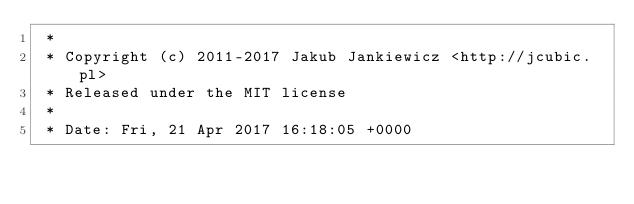<code> <loc_0><loc_0><loc_500><loc_500><_CSS_> *
 * Copyright (c) 2011-2017 Jakub Jankiewicz <http://jcubic.pl>
 * Released under the MIT license
 *
 * Date: Fri, 21 Apr 2017 16:18:05 +0000</code> 